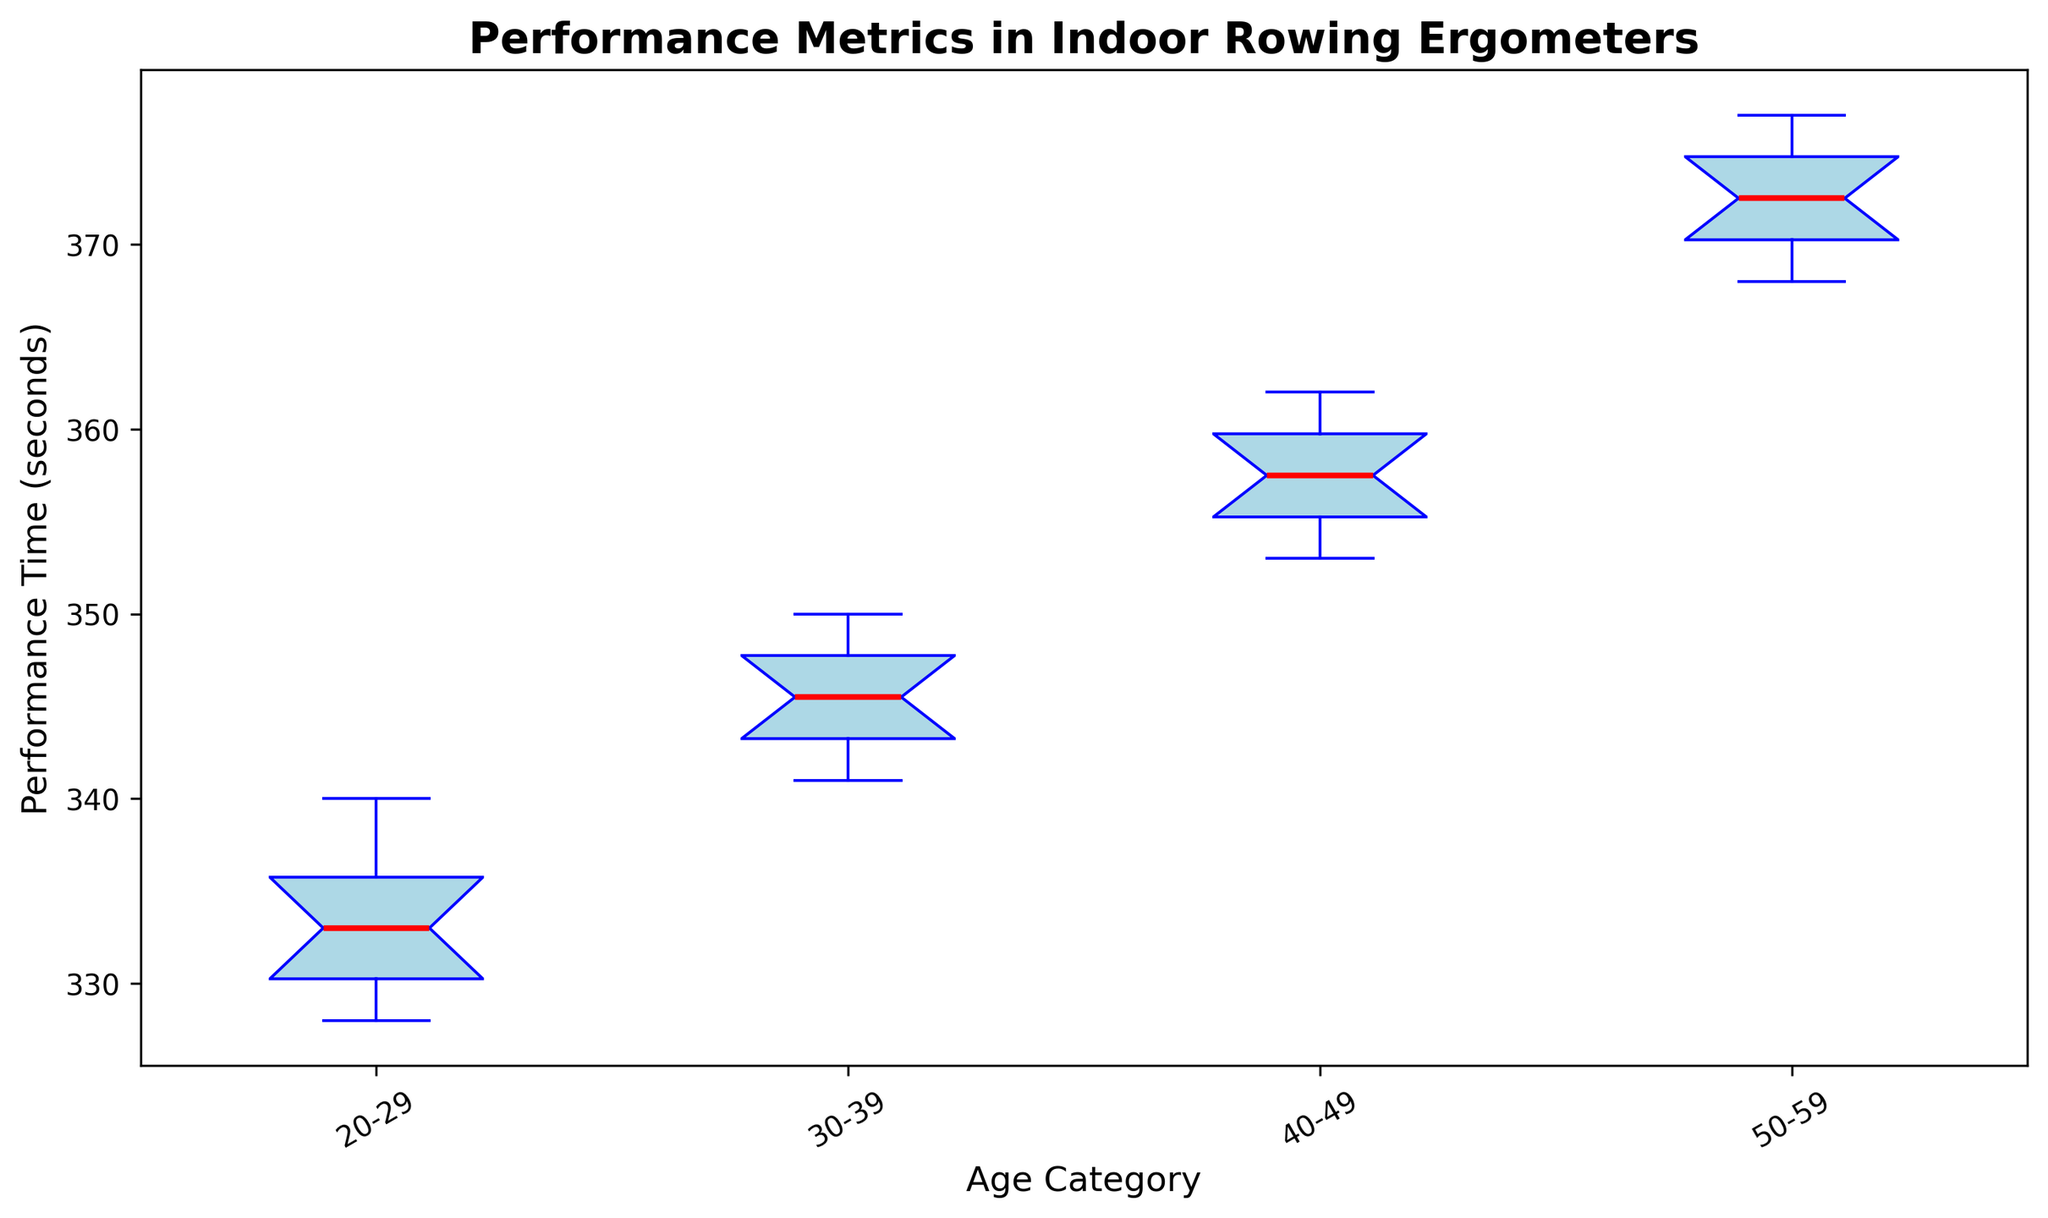How does the performance time of the youngest age category compare with the oldest age category? To compare the performance times, observe the boxes of the "20-29" and "50-59" age categories. The "20-29" age category has shorter times (indicating faster performance) compared to the "50-59" age category, whose performance times are higher.
Answer: The "20-29" age category has shorter performance times than the "50-59" age category What is the range of the performance times for the 30-39 age category? The range is determined by the difference between the maximum and minimum values shown in the whiskers of the box plot. For the "30-39" age category, the maximum value is around 350 seconds and the minimum value is around 341 seconds, so the range is 350 - 341 = 9 seconds.
Answer: 9 seconds Which age category has the smallest interquartile range (IQR)? The interquartile range is the length of the box in the box plot. By comparing the lengths of the boxes for each age category, the "20-29" age category appears to have the smallest IQR.
Answer: "20-29" Does the median performance time increase or decrease with age? The median is represented by the line inside the box. Observing the median lines from left to right (from younger to older categories), it is evident that the median performance time increases with age.
Answer: Increases What is the median performance time for the 40-49 age category? The median performance time is indicated by the line inside the box for the "40-49" age category. It is approximately at 357 seconds.
Answer: 357 seconds Which age category has the greatest variation in performance times? Variation is shown by the length of the whiskers in the box plot. The "50-59" age category has the longest whiskers, indicating the greatest variation.
Answer: "50-59" age category Between which age categories is the difference in median performance times the greatest? To find this, compare the vertical distance between the median lines of each age category. The largest gap occurs between the "50-59" and "40-49" age categories.
Answer: Between "50-59" and "40-49" Are there any outliers in the 30-39 age category? Outliers would be represented by dots outside the whiskers of the box plot. In the "30-39" age category, there are no such dots, so there are no outliers.
Answer: No What is the color used to denote the median in the box plot and what is the implication of its appearance? The median is denoted by a red line. This color highlights the central value of the data within each age category.
Answer: Red 